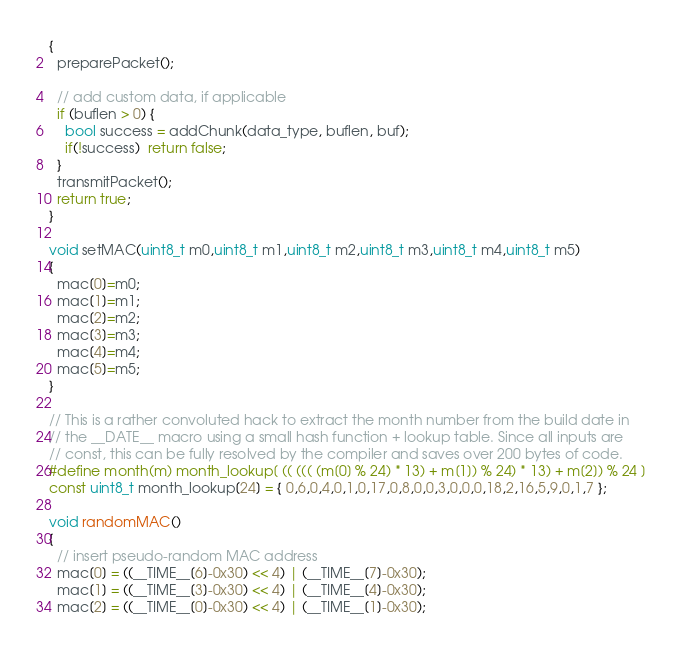Convert code to text. <code><loc_0><loc_0><loc_500><loc_500><_C_>{
  preparePacket();
  
  // add custom data, if applicable
  if (buflen > 0) {
    bool success = addChunk(data_type, buflen, buf);
    if(!success)  return false;
  }
  transmitPacket();
  return true;
}

void setMAC(uint8_t m0,uint8_t m1,uint8_t m2,uint8_t m3,uint8_t m4,uint8_t m5)
{
  mac[0]=m0;
  mac[1]=m1;
  mac[2]=m2;
  mac[3]=m3;
  mac[4]=m4;
  mac[5]=m5;
}

// This is a rather convoluted hack to extract the month number from the build date in
// the __DATE__ macro using a small hash function + lookup table. Since all inputs are
// const, this can be fully resolved by the compiler and saves over 200 bytes of code.
#define month(m) month_lookup[ (( ((( (m[0] % 24) * 13) + m[1]) % 24) * 13) + m[2]) % 24 ]
const uint8_t month_lookup[24] = { 0,6,0,4,0,1,0,17,0,8,0,0,3,0,0,0,18,2,16,5,9,0,1,7 };

void randomMAC()
{
  // insert pseudo-random MAC address
  mac[0] = ((__TIME__[6]-0x30) << 4) | (__TIME__[7]-0x30);
  mac[1] = ((__TIME__[3]-0x30) << 4) | (__TIME__[4]-0x30);
  mac[2] = ((__TIME__[0]-0x30) << 4) | (__TIME__[1]-0x30);</code> 